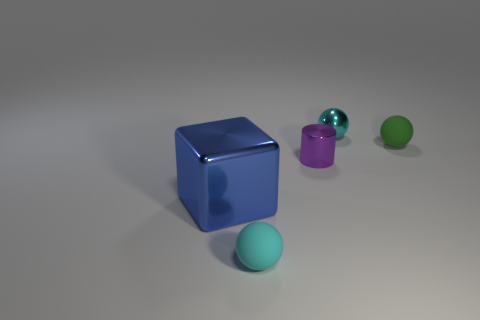Add 3 big yellow rubber spheres. How many objects exist? 8 Subtract all cylinders. How many objects are left? 4 Add 3 big cubes. How many big cubes exist? 4 Subtract 1 green balls. How many objects are left? 4 Subtract all big blue shiny blocks. Subtract all spheres. How many objects are left? 1 Add 1 purple shiny cylinders. How many purple shiny cylinders are left? 2 